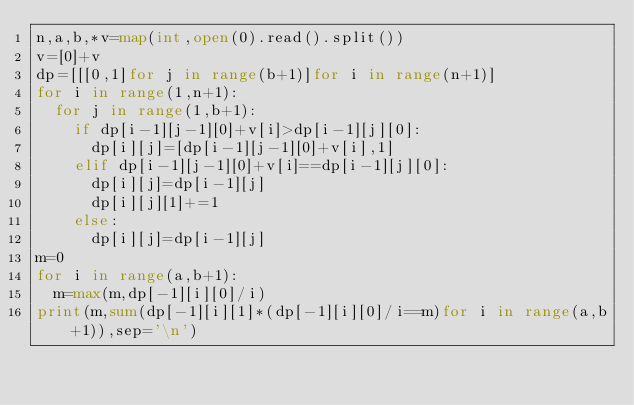<code> <loc_0><loc_0><loc_500><loc_500><_Python_>n,a,b,*v=map(int,open(0).read().split())
v=[0]+v
dp=[[[0,1]for j in range(b+1)]for i in range(n+1)]
for i in range(1,n+1):
  for j in range(1,b+1):
    if dp[i-1][j-1][0]+v[i]>dp[i-1][j][0]:
      dp[i][j]=[dp[i-1][j-1][0]+v[i],1]
    elif dp[i-1][j-1][0]+v[i]==dp[i-1][j][0]:
      dp[i][j]=dp[i-1][j]
      dp[i][j][1]+=1
    else:
      dp[i][j]=dp[i-1][j]
m=0
for i in range(a,b+1):
  m=max(m,dp[-1][i][0]/i)
print(m,sum(dp[-1][i][1]*(dp[-1][i][0]/i==m)for i in range(a,b+1)),sep='\n')</code> 